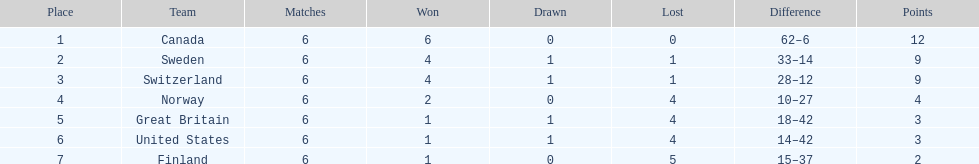How many teams achieved at least 4 wins? 3. 